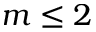<formula> <loc_0><loc_0><loc_500><loc_500>m \leq 2</formula> 